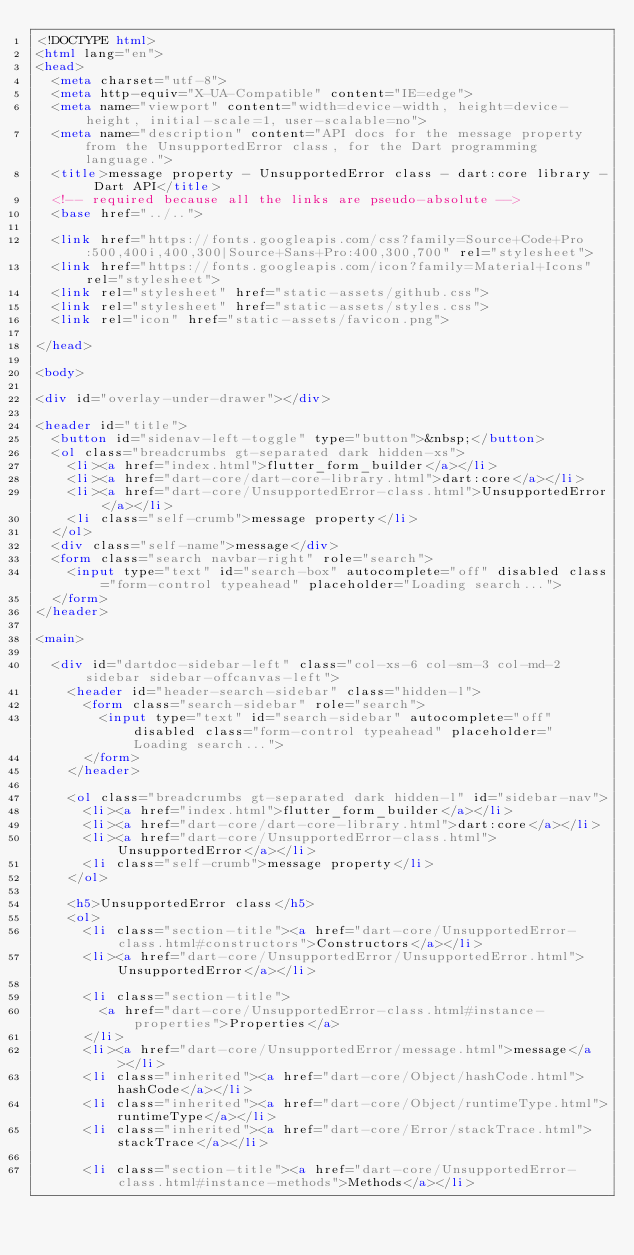<code> <loc_0><loc_0><loc_500><loc_500><_HTML_><!DOCTYPE html>
<html lang="en">
<head>
  <meta charset="utf-8">
  <meta http-equiv="X-UA-Compatible" content="IE=edge">
  <meta name="viewport" content="width=device-width, height=device-height, initial-scale=1, user-scalable=no">
  <meta name="description" content="API docs for the message property from the UnsupportedError class, for the Dart programming language.">
  <title>message property - UnsupportedError class - dart:core library - Dart API</title>
  <!-- required because all the links are pseudo-absolute -->
  <base href="../..">

  <link href="https://fonts.googleapis.com/css?family=Source+Code+Pro:500,400i,400,300|Source+Sans+Pro:400,300,700" rel="stylesheet">
  <link href="https://fonts.googleapis.com/icon?family=Material+Icons" rel="stylesheet">
  <link rel="stylesheet" href="static-assets/github.css">
  <link rel="stylesheet" href="static-assets/styles.css">
  <link rel="icon" href="static-assets/favicon.png">
  
</head>

<body>

<div id="overlay-under-drawer"></div>

<header id="title">
  <button id="sidenav-left-toggle" type="button">&nbsp;</button>
  <ol class="breadcrumbs gt-separated dark hidden-xs">
    <li><a href="index.html">flutter_form_builder</a></li>
    <li><a href="dart-core/dart-core-library.html">dart:core</a></li>
    <li><a href="dart-core/UnsupportedError-class.html">UnsupportedError</a></li>
    <li class="self-crumb">message property</li>
  </ol>
  <div class="self-name">message</div>
  <form class="search navbar-right" role="search">
    <input type="text" id="search-box" autocomplete="off" disabled class="form-control typeahead" placeholder="Loading search...">
  </form>
</header>

<main>

  <div id="dartdoc-sidebar-left" class="col-xs-6 col-sm-3 col-md-2 sidebar sidebar-offcanvas-left">
    <header id="header-search-sidebar" class="hidden-l">
      <form class="search-sidebar" role="search">
        <input type="text" id="search-sidebar" autocomplete="off" disabled class="form-control typeahead" placeholder="Loading search...">
      </form>
    </header>
    
    <ol class="breadcrumbs gt-separated dark hidden-l" id="sidebar-nav">
      <li><a href="index.html">flutter_form_builder</a></li>
      <li><a href="dart-core/dart-core-library.html">dart:core</a></li>
      <li><a href="dart-core/UnsupportedError-class.html">UnsupportedError</a></li>
      <li class="self-crumb">message property</li>
    </ol>
    
    <h5>UnsupportedError class</h5>
    <ol>
      <li class="section-title"><a href="dart-core/UnsupportedError-class.html#constructors">Constructors</a></li>
      <li><a href="dart-core/UnsupportedError/UnsupportedError.html">UnsupportedError</a></li>
    
      <li class="section-title">
        <a href="dart-core/UnsupportedError-class.html#instance-properties">Properties</a>
      </li>
      <li><a href="dart-core/UnsupportedError/message.html">message</a></li>
      <li class="inherited"><a href="dart-core/Object/hashCode.html">hashCode</a></li>
      <li class="inherited"><a href="dart-core/Object/runtimeType.html">runtimeType</a></li>
      <li class="inherited"><a href="dart-core/Error/stackTrace.html">stackTrace</a></li>
    
      <li class="section-title"><a href="dart-core/UnsupportedError-class.html#instance-methods">Methods</a></li></code> 